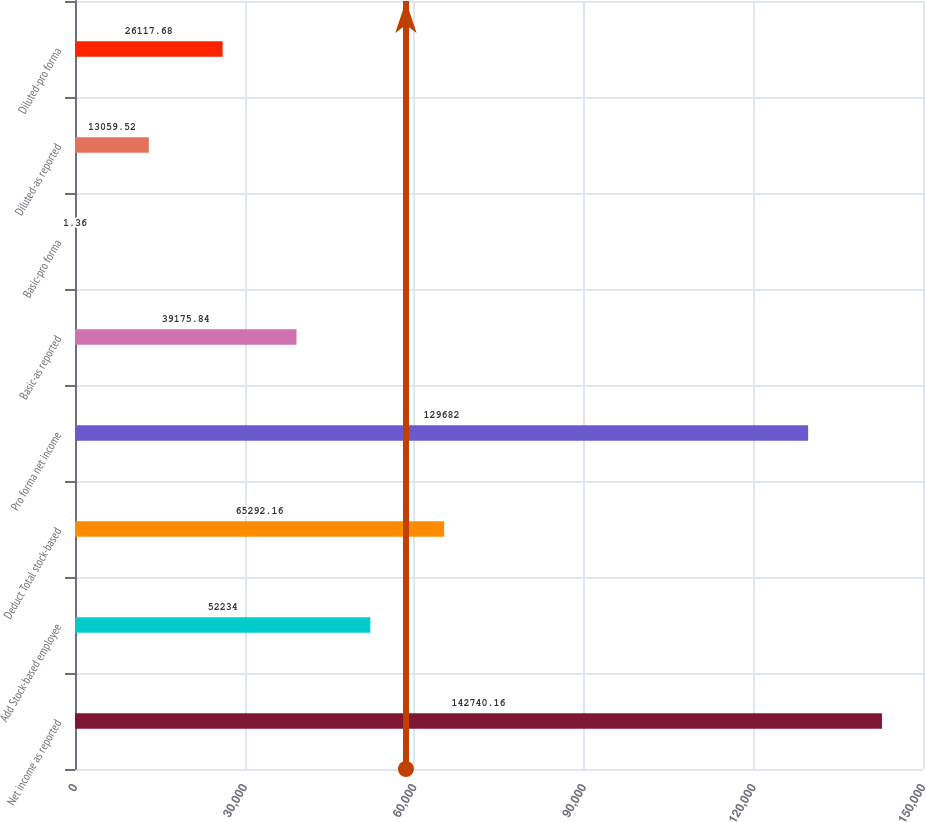<chart> <loc_0><loc_0><loc_500><loc_500><bar_chart><fcel>Net income as reported<fcel>Add Stock-based employee<fcel>Deduct Total stock-based<fcel>Pro forma net income<fcel>Basic-as reported<fcel>Basic-pro forma<fcel>Diluted-as reported<fcel>Diluted-pro forma<nl><fcel>142740<fcel>52234<fcel>65292.2<fcel>129682<fcel>39175.8<fcel>1.36<fcel>13059.5<fcel>26117.7<nl></chart> 